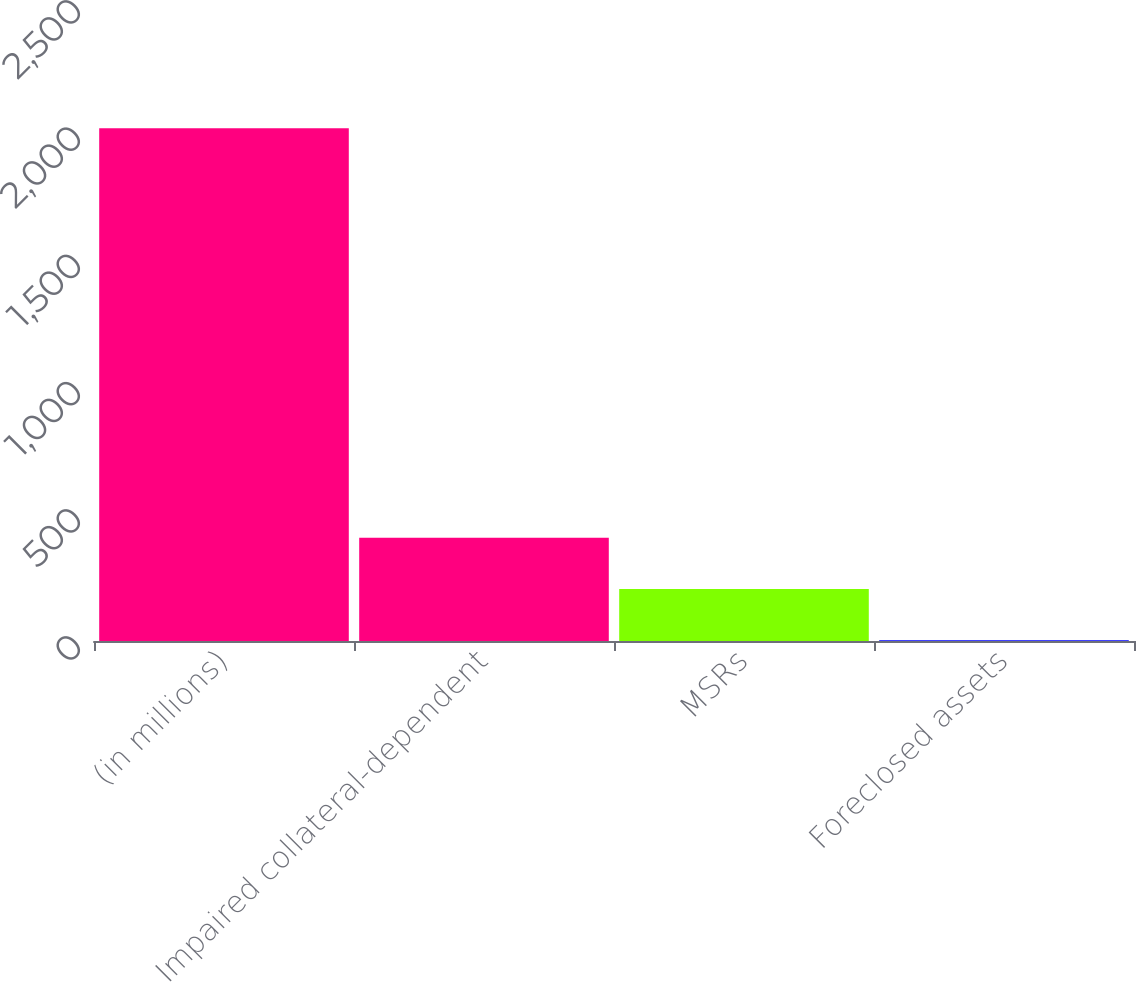<chart> <loc_0><loc_0><loc_500><loc_500><bar_chart><fcel>(in millions)<fcel>Impaired collateral-dependent<fcel>MSRs<fcel>Foreclosed assets<nl><fcel>2016<fcel>405.6<fcel>204.3<fcel>3<nl></chart> 